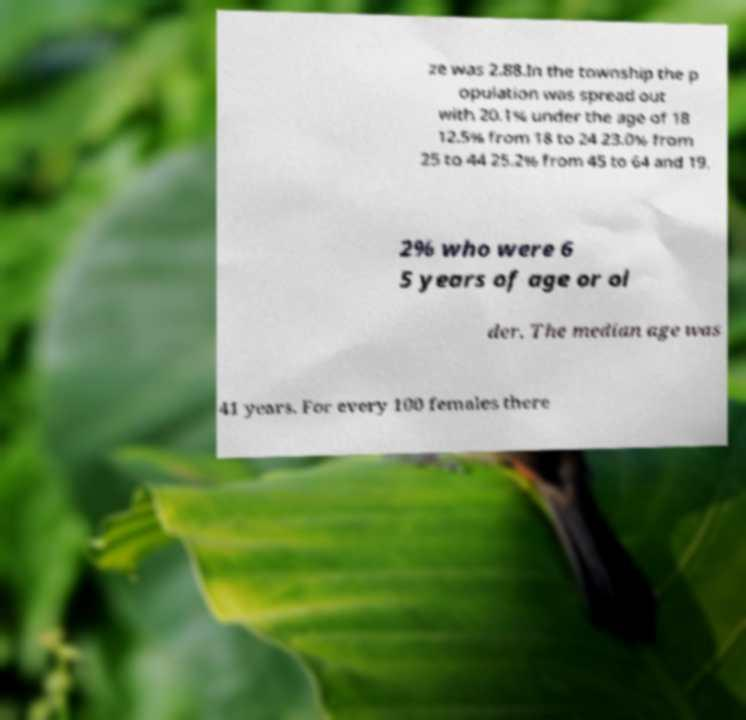Could you assist in decoding the text presented in this image and type it out clearly? ze was 2.88.In the township the p opulation was spread out with 20.1% under the age of 18 12.5% from 18 to 24 23.0% from 25 to 44 25.2% from 45 to 64 and 19. 2% who were 6 5 years of age or ol der. The median age was 41 years. For every 100 females there 